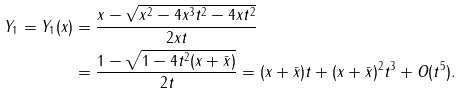Convert formula to latex. <formula><loc_0><loc_0><loc_500><loc_500>Y _ { 1 } = Y _ { 1 } ( x ) & = \frac { x - \sqrt { x ^ { 2 } - 4 x ^ { 3 } t ^ { 2 } - 4 x t ^ { 2 } } } { 2 x t } \\ & = \frac { 1 - \sqrt { 1 - 4 t ^ { 2 } ( x + \bar { x } ) } } { 2 t } = ( x + \bar { x } ) t + ( x + \bar { x } ) ^ { 2 } t ^ { 3 } + O ( t ^ { 5 } ) .</formula> 